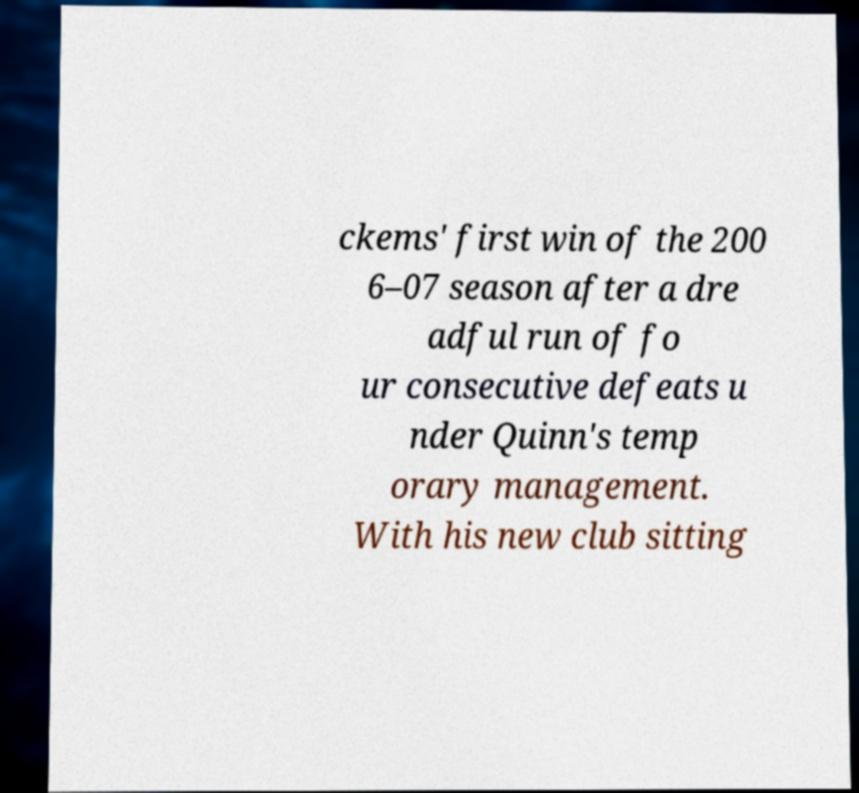I need the written content from this picture converted into text. Can you do that? ckems' first win of the 200 6–07 season after a dre adful run of fo ur consecutive defeats u nder Quinn's temp orary management. With his new club sitting 